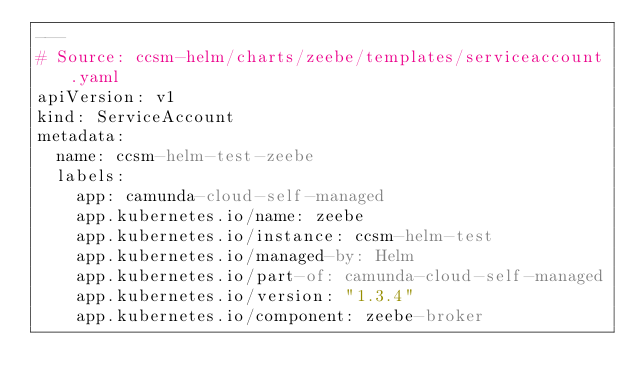Convert code to text. <code><loc_0><loc_0><loc_500><loc_500><_YAML_>---
# Source: ccsm-helm/charts/zeebe/templates/serviceaccount.yaml
apiVersion: v1
kind: ServiceAccount
metadata:
  name: ccsm-helm-test-zeebe
  labels:
    app: camunda-cloud-self-managed
    app.kubernetes.io/name: zeebe
    app.kubernetes.io/instance: ccsm-helm-test
    app.kubernetes.io/managed-by: Helm
    app.kubernetes.io/part-of: camunda-cloud-self-managed
    app.kubernetes.io/version: "1.3.4"
    app.kubernetes.io/component: zeebe-broker</code> 